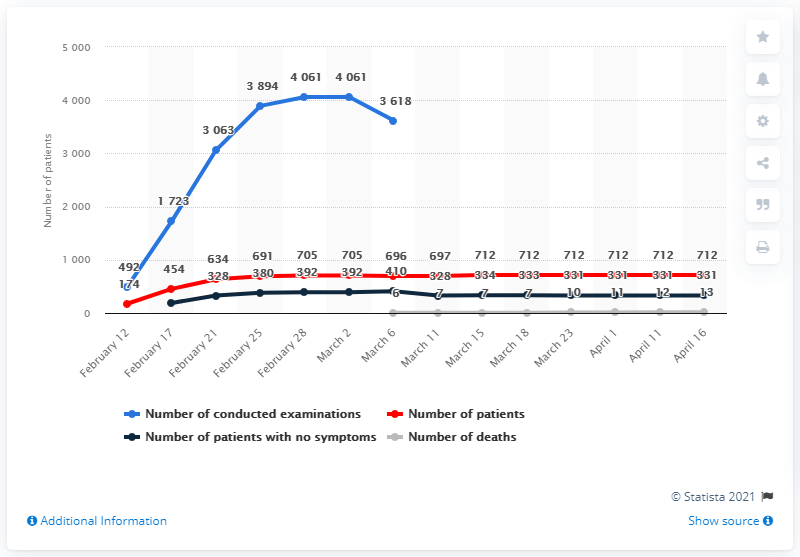Point out several critical features in this image. The Diamond Princess cruise ship reported 712 cases of COVID-19 infection among its passengers and crew. 